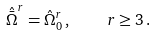Convert formula to latex. <formula><loc_0><loc_0><loc_500><loc_500>{ \hat { \bar { \Omega } } } ^ { r } = { \hat { \Omega } } _ { 0 } ^ { r } \, , \quad r \geq 3 \, .</formula> 